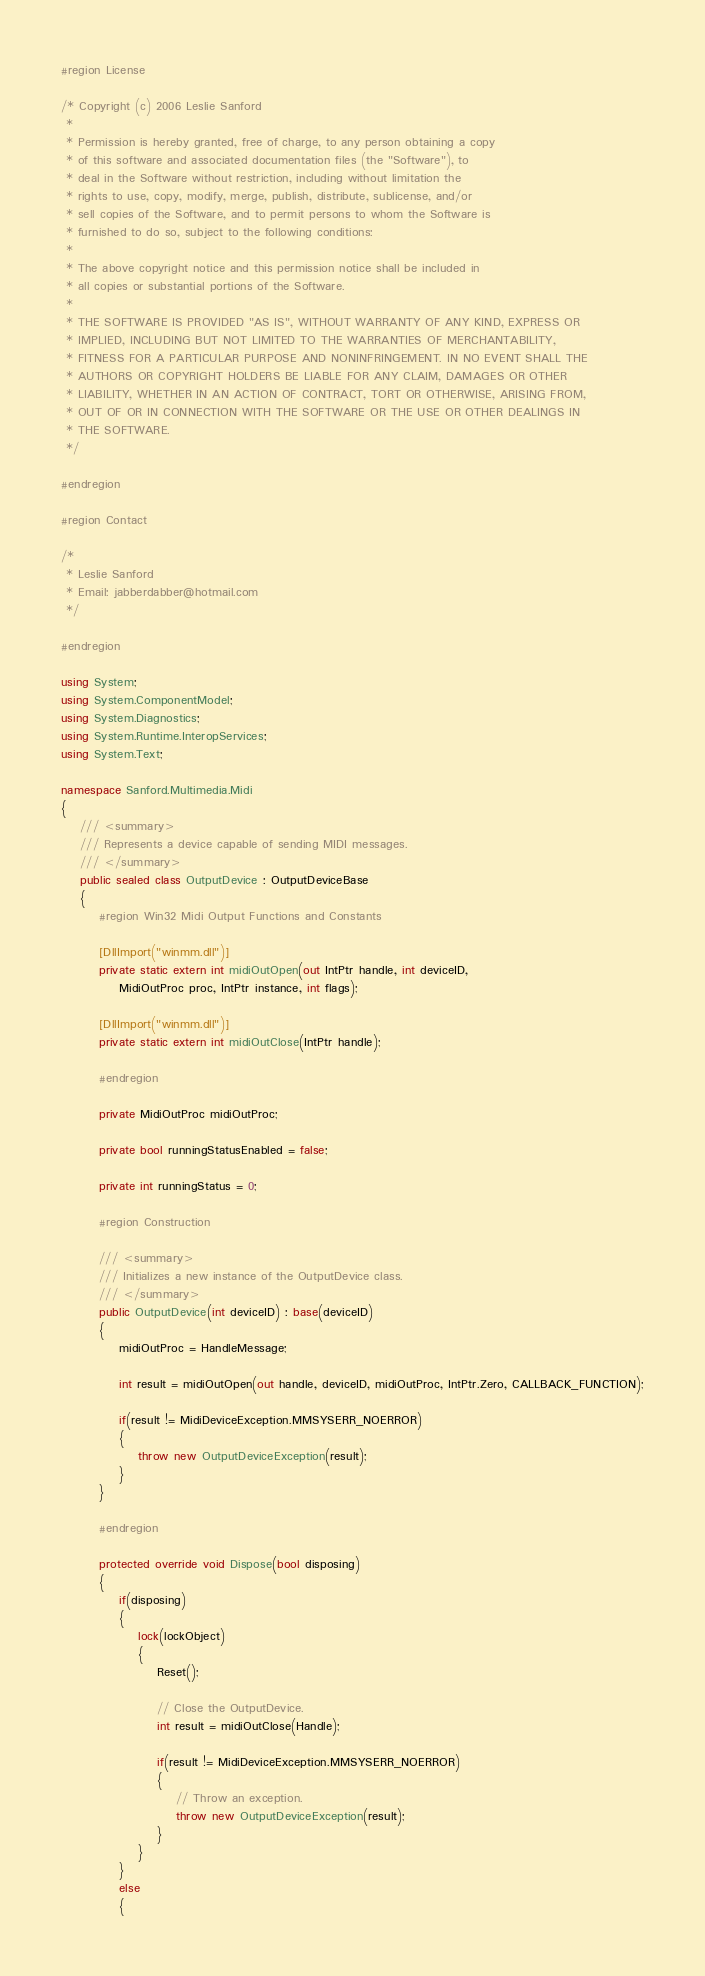<code> <loc_0><loc_0><loc_500><loc_500><_C#_>#region License

/* Copyright (c) 2006 Leslie Sanford
 * 
 * Permission is hereby granted, free of charge, to any person obtaining a copy 
 * of this software and associated documentation files (the "Software"), to 
 * deal in the Software without restriction, including without limitation the 
 * rights to use, copy, modify, merge, publish, distribute, sublicense, and/or 
 * sell copies of the Software, and to permit persons to whom the Software is 
 * furnished to do so, subject to the following conditions:
 * 
 * The above copyright notice and this permission notice shall be included in 
 * all copies or substantial portions of the Software. 
 * 
 * THE SOFTWARE IS PROVIDED "AS IS", WITHOUT WARRANTY OF ANY KIND, EXPRESS OR 
 * IMPLIED, INCLUDING BUT NOT LIMITED TO THE WARRANTIES OF MERCHANTABILITY, 
 * FITNESS FOR A PARTICULAR PURPOSE AND NONINFRINGEMENT. IN NO EVENT SHALL THE 
 * AUTHORS OR COPYRIGHT HOLDERS BE LIABLE FOR ANY CLAIM, DAMAGES OR OTHER 
 * LIABILITY, WHETHER IN AN ACTION OF CONTRACT, TORT OR OTHERWISE, ARISING FROM, 
 * OUT OF OR IN CONNECTION WITH THE SOFTWARE OR THE USE OR OTHER DEALINGS IN 
 * THE SOFTWARE.
 */

#endregion

#region Contact

/*
 * Leslie Sanford
 * Email: jabberdabber@hotmail.com
 */

#endregion

using System;
using System.ComponentModel;
using System.Diagnostics;
using System.Runtime.InteropServices;
using System.Text;

namespace Sanford.Multimedia.Midi
{
	/// <summary>
	/// Represents a device capable of sending MIDI messages.
	/// </summary>
	public sealed class OutputDevice : OutputDeviceBase
	{
        #region Win32 Midi Output Functions and Constants

        [DllImport("winmm.dll")]
        private static extern int midiOutOpen(out IntPtr handle, int deviceID,
            MidiOutProc proc, IntPtr instance, int flags);

        [DllImport("winmm.dll")]
        private static extern int midiOutClose(IntPtr handle);

        #endregion 

        private MidiOutProc midiOutProc;

        private bool runningStatusEnabled = false;

        private int runningStatus = 0;        

        #region Construction

        /// <summary>
        /// Initializes a new instance of the OutputDevice class.
        /// </summary>
        public OutputDevice(int deviceID) : base(deviceID)
        {
            midiOutProc = HandleMessage;

            int result = midiOutOpen(out handle, deviceID, midiOutProc, IntPtr.Zero, CALLBACK_FUNCTION);

            if(result != MidiDeviceException.MMSYSERR_NOERROR)
            {
                throw new OutputDeviceException(result);
            }
        }

        #endregion     
   
        protected override void Dispose(bool disposing)
        {
            if(disposing)
            {
                lock(lockObject)
                {
                    Reset();

                    // Close the OutputDevice.
                    int result = midiOutClose(Handle);

                    if(result != MidiDeviceException.MMSYSERR_NOERROR)
                    {
                        // Throw an exception.
                        throw new OutputDeviceException(result);
                    }
                }
            }
            else
            {</code> 